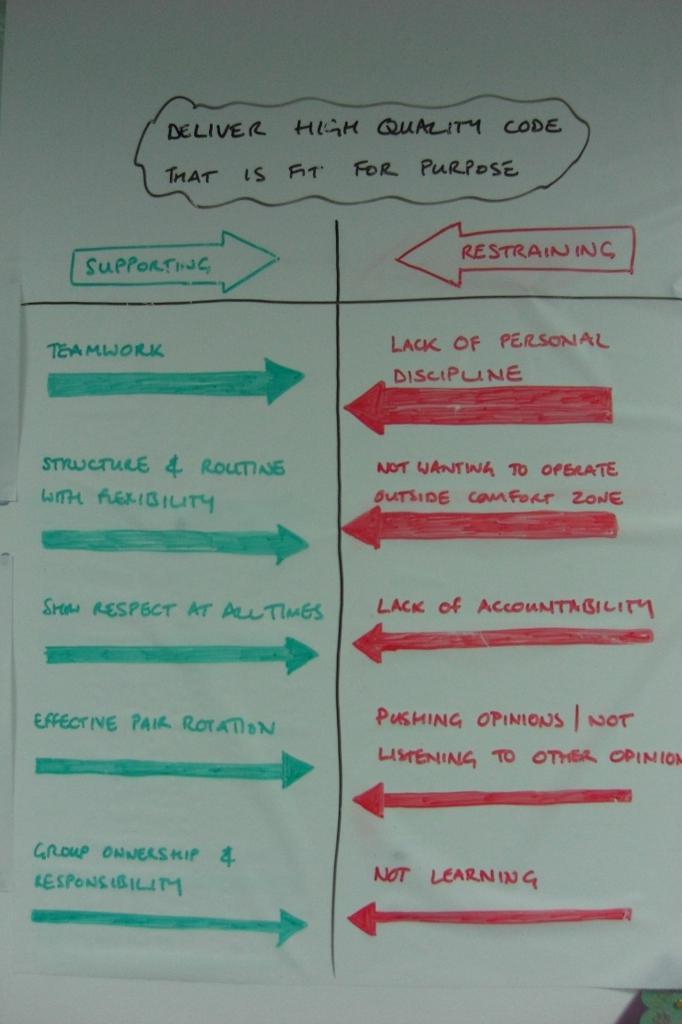What is across from supporting?
Offer a very short reply. Restraining. 